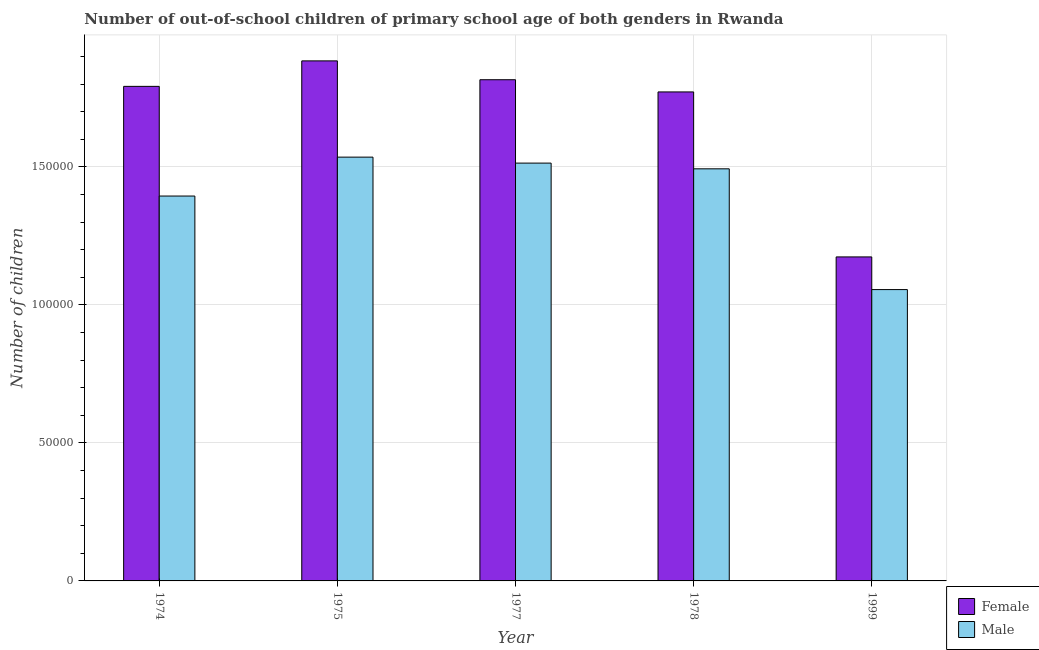How many groups of bars are there?
Ensure brevity in your answer.  5. How many bars are there on the 1st tick from the right?
Offer a terse response. 2. What is the label of the 2nd group of bars from the left?
Provide a short and direct response. 1975. In how many cases, is the number of bars for a given year not equal to the number of legend labels?
Provide a succinct answer. 0. What is the number of male out-of-school students in 1975?
Keep it short and to the point. 1.54e+05. Across all years, what is the maximum number of male out-of-school students?
Provide a succinct answer. 1.54e+05. Across all years, what is the minimum number of female out-of-school students?
Give a very brief answer. 1.17e+05. In which year was the number of female out-of-school students maximum?
Your response must be concise. 1975. What is the total number of female out-of-school students in the graph?
Give a very brief answer. 8.44e+05. What is the difference between the number of female out-of-school students in 1974 and that in 1978?
Keep it short and to the point. 2012. What is the difference between the number of female out-of-school students in 1977 and the number of male out-of-school students in 1975?
Provide a short and direct response. -6831. What is the average number of female out-of-school students per year?
Your answer should be compact. 1.69e+05. In how many years, is the number of male out-of-school students greater than 20000?
Provide a short and direct response. 5. What is the ratio of the number of female out-of-school students in 1978 to that in 1999?
Offer a very short reply. 1.51. Is the number of male out-of-school students in 1975 less than that in 1999?
Offer a very short reply. No. What is the difference between the highest and the second highest number of male out-of-school students?
Your response must be concise. 2163. What is the difference between the highest and the lowest number of male out-of-school students?
Provide a short and direct response. 4.80e+04. Is the sum of the number of male out-of-school students in 1975 and 1999 greater than the maximum number of female out-of-school students across all years?
Your answer should be very brief. Yes. What does the 2nd bar from the left in 1978 represents?
Offer a terse response. Male. How many bars are there?
Offer a terse response. 10. Are all the bars in the graph horizontal?
Offer a very short reply. No. How many years are there in the graph?
Offer a terse response. 5. What is the difference between two consecutive major ticks on the Y-axis?
Your response must be concise. 5.00e+04. What is the title of the graph?
Your answer should be very brief. Number of out-of-school children of primary school age of both genders in Rwanda. What is the label or title of the Y-axis?
Make the answer very short. Number of children. What is the Number of children of Female in 1974?
Give a very brief answer. 1.79e+05. What is the Number of children of Male in 1974?
Ensure brevity in your answer.  1.39e+05. What is the Number of children in Female in 1975?
Offer a very short reply. 1.88e+05. What is the Number of children of Male in 1975?
Your response must be concise. 1.54e+05. What is the Number of children of Female in 1977?
Ensure brevity in your answer.  1.82e+05. What is the Number of children in Male in 1977?
Keep it short and to the point. 1.51e+05. What is the Number of children of Female in 1978?
Make the answer very short. 1.77e+05. What is the Number of children in Male in 1978?
Provide a short and direct response. 1.49e+05. What is the Number of children in Female in 1999?
Make the answer very short. 1.17e+05. What is the Number of children of Male in 1999?
Keep it short and to the point. 1.06e+05. Across all years, what is the maximum Number of children of Female?
Provide a short and direct response. 1.88e+05. Across all years, what is the maximum Number of children of Male?
Provide a short and direct response. 1.54e+05. Across all years, what is the minimum Number of children in Female?
Your answer should be very brief. 1.17e+05. Across all years, what is the minimum Number of children in Male?
Your answer should be compact. 1.06e+05. What is the total Number of children of Female in the graph?
Provide a succinct answer. 8.44e+05. What is the total Number of children of Male in the graph?
Your answer should be compact. 6.99e+05. What is the difference between the Number of children in Female in 1974 and that in 1975?
Provide a short and direct response. -9238. What is the difference between the Number of children of Male in 1974 and that in 1975?
Your answer should be very brief. -1.41e+04. What is the difference between the Number of children in Female in 1974 and that in 1977?
Give a very brief answer. -2407. What is the difference between the Number of children of Male in 1974 and that in 1977?
Provide a short and direct response. -1.19e+04. What is the difference between the Number of children in Female in 1974 and that in 1978?
Offer a very short reply. 2012. What is the difference between the Number of children of Male in 1974 and that in 1978?
Keep it short and to the point. -9868. What is the difference between the Number of children in Female in 1974 and that in 1999?
Ensure brevity in your answer.  6.18e+04. What is the difference between the Number of children in Male in 1974 and that in 1999?
Offer a very short reply. 3.39e+04. What is the difference between the Number of children of Female in 1975 and that in 1977?
Offer a terse response. 6831. What is the difference between the Number of children in Male in 1975 and that in 1977?
Your answer should be compact. 2163. What is the difference between the Number of children in Female in 1975 and that in 1978?
Offer a terse response. 1.12e+04. What is the difference between the Number of children in Male in 1975 and that in 1978?
Provide a short and direct response. 4231. What is the difference between the Number of children in Female in 1975 and that in 1999?
Ensure brevity in your answer.  7.10e+04. What is the difference between the Number of children in Male in 1975 and that in 1999?
Your answer should be compact. 4.80e+04. What is the difference between the Number of children in Female in 1977 and that in 1978?
Make the answer very short. 4419. What is the difference between the Number of children of Male in 1977 and that in 1978?
Keep it short and to the point. 2068. What is the difference between the Number of children of Female in 1977 and that in 1999?
Your response must be concise. 6.42e+04. What is the difference between the Number of children of Male in 1977 and that in 1999?
Offer a very short reply. 4.58e+04. What is the difference between the Number of children of Female in 1978 and that in 1999?
Offer a very short reply. 5.98e+04. What is the difference between the Number of children in Male in 1978 and that in 1999?
Provide a succinct answer. 4.38e+04. What is the difference between the Number of children in Female in 1974 and the Number of children in Male in 1975?
Give a very brief answer. 2.56e+04. What is the difference between the Number of children of Female in 1974 and the Number of children of Male in 1977?
Your answer should be compact. 2.78e+04. What is the difference between the Number of children of Female in 1974 and the Number of children of Male in 1978?
Give a very brief answer. 2.99e+04. What is the difference between the Number of children in Female in 1974 and the Number of children in Male in 1999?
Provide a succinct answer. 7.36e+04. What is the difference between the Number of children in Female in 1975 and the Number of children in Male in 1977?
Provide a succinct answer. 3.70e+04. What is the difference between the Number of children in Female in 1975 and the Number of children in Male in 1978?
Keep it short and to the point. 3.91e+04. What is the difference between the Number of children of Female in 1975 and the Number of children of Male in 1999?
Give a very brief answer. 8.29e+04. What is the difference between the Number of children in Female in 1977 and the Number of children in Male in 1978?
Keep it short and to the point. 3.23e+04. What is the difference between the Number of children in Female in 1977 and the Number of children in Male in 1999?
Give a very brief answer. 7.60e+04. What is the difference between the Number of children in Female in 1978 and the Number of children in Male in 1999?
Your response must be concise. 7.16e+04. What is the average Number of children in Female per year?
Give a very brief answer. 1.69e+05. What is the average Number of children in Male per year?
Your answer should be very brief. 1.40e+05. In the year 1974, what is the difference between the Number of children of Female and Number of children of Male?
Your response must be concise. 3.97e+04. In the year 1975, what is the difference between the Number of children of Female and Number of children of Male?
Offer a very short reply. 3.49e+04. In the year 1977, what is the difference between the Number of children of Female and Number of children of Male?
Your answer should be very brief. 3.02e+04. In the year 1978, what is the difference between the Number of children of Female and Number of children of Male?
Give a very brief answer. 2.79e+04. In the year 1999, what is the difference between the Number of children in Female and Number of children in Male?
Make the answer very short. 1.18e+04. What is the ratio of the Number of children of Female in 1974 to that in 1975?
Give a very brief answer. 0.95. What is the ratio of the Number of children of Male in 1974 to that in 1975?
Keep it short and to the point. 0.91. What is the ratio of the Number of children of Female in 1974 to that in 1977?
Provide a short and direct response. 0.99. What is the ratio of the Number of children in Male in 1974 to that in 1977?
Provide a short and direct response. 0.92. What is the ratio of the Number of children of Female in 1974 to that in 1978?
Your answer should be compact. 1.01. What is the ratio of the Number of children in Male in 1974 to that in 1978?
Ensure brevity in your answer.  0.93. What is the ratio of the Number of children in Female in 1974 to that in 1999?
Keep it short and to the point. 1.53. What is the ratio of the Number of children in Male in 1974 to that in 1999?
Make the answer very short. 1.32. What is the ratio of the Number of children in Female in 1975 to that in 1977?
Make the answer very short. 1.04. What is the ratio of the Number of children of Male in 1975 to that in 1977?
Your answer should be very brief. 1.01. What is the ratio of the Number of children in Female in 1975 to that in 1978?
Provide a succinct answer. 1.06. What is the ratio of the Number of children in Male in 1975 to that in 1978?
Provide a succinct answer. 1.03. What is the ratio of the Number of children of Female in 1975 to that in 1999?
Offer a terse response. 1.6. What is the ratio of the Number of children in Male in 1975 to that in 1999?
Provide a short and direct response. 1.45. What is the ratio of the Number of children in Female in 1977 to that in 1978?
Give a very brief answer. 1.02. What is the ratio of the Number of children of Male in 1977 to that in 1978?
Provide a succinct answer. 1.01. What is the ratio of the Number of children of Female in 1977 to that in 1999?
Your answer should be very brief. 1.55. What is the ratio of the Number of children of Male in 1977 to that in 1999?
Offer a terse response. 1.43. What is the ratio of the Number of children of Female in 1978 to that in 1999?
Your answer should be very brief. 1.51. What is the ratio of the Number of children of Male in 1978 to that in 1999?
Give a very brief answer. 1.41. What is the difference between the highest and the second highest Number of children of Female?
Your answer should be very brief. 6831. What is the difference between the highest and the second highest Number of children in Male?
Your answer should be compact. 2163. What is the difference between the highest and the lowest Number of children in Female?
Offer a terse response. 7.10e+04. What is the difference between the highest and the lowest Number of children of Male?
Your answer should be very brief. 4.80e+04. 